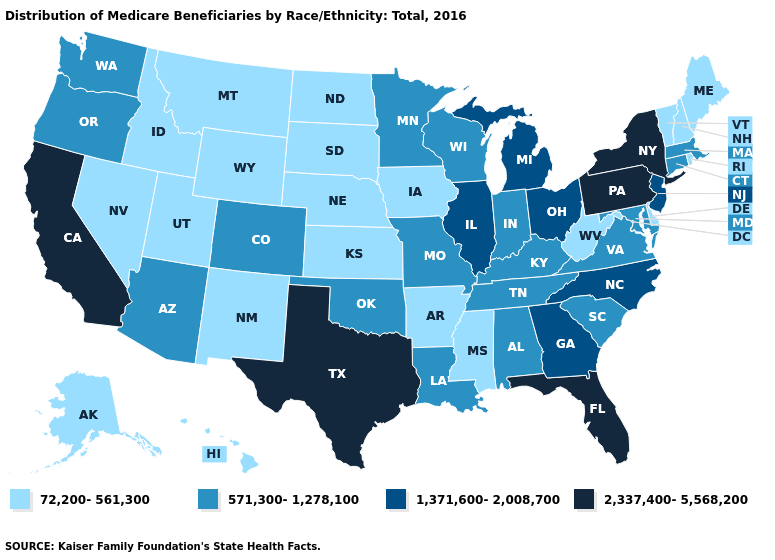What is the value of Texas?
Keep it brief. 2,337,400-5,568,200. Name the states that have a value in the range 1,371,600-2,008,700?
Give a very brief answer. Georgia, Illinois, Michigan, New Jersey, North Carolina, Ohio. What is the lowest value in states that border California?
Be succinct. 72,200-561,300. Name the states that have a value in the range 72,200-561,300?
Short answer required. Alaska, Arkansas, Delaware, Hawaii, Idaho, Iowa, Kansas, Maine, Mississippi, Montana, Nebraska, Nevada, New Hampshire, New Mexico, North Dakota, Rhode Island, South Dakota, Utah, Vermont, West Virginia, Wyoming. Name the states that have a value in the range 72,200-561,300?
Be succinct. Alaska, Arkansas, Delaware, Hawaii, Idaho, Iowa, Kansas, Maine, Mississippi, Montana, Nebraska, Nevada, New Hampshire, New Mexico, North Dakota, Rhode Island, South Dakota, Utah, Vermont, West Virginia, Wyoming. Among the states that border New Mexico , does Utah have the lowest value?
Answer briefly. Yes. What is the value of Nevada?
Keep it brief. 72,200-561,300. Which states have the lowest value in the South?
Keep it brief. Arkansas, Delaware, Mississippi, West Virginia. Does the first symbol in the legend represent the smallest category?
Be succinct. Yes. Does Indiana have a lower value than South Carolina?
Short answer required. No. Name the states that have a value in the range 571,300-1,278,100?
Answer briefly. Alabama, Arizona, Colorado, Connecticut, Indiana, Kentucky, Louisiana, Maryland, Massachusetts, Minnesota, Missouri, Oklahoma, Oregon, South Carolina, Tennessee, Virginia, Washington, Wisconsin. Does Texas have the highest value in the South?
Concise answer only. Yes. Name the states that have a value in the range 1,371,600-2,008,700?
Concise answer only. Georgia, Illinois, Michigan, New Jersey, North Carolina, Ohio. Does the first symbol in the legend represent the smallest category?
Write a very short answer. Yes. Does New Hampshire have a lower value than New York?
Quick response, please. Yes. 